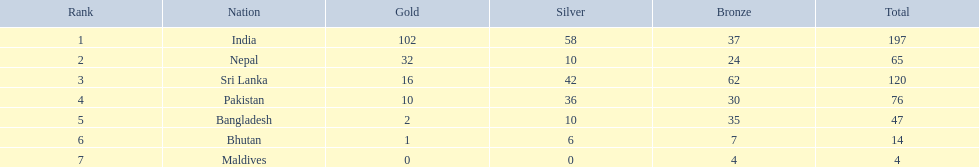What are all the nations mentioned in the chart? India, Nepal, Sri Lanka, Pakistan, Bangladesh, Bhutan, Maldives. Which one is not india? Nepal, Sri Lanka, Pakistan, Bangladesh, Bhutan, Maldives. Among them, which is the initial one? Nepal. 